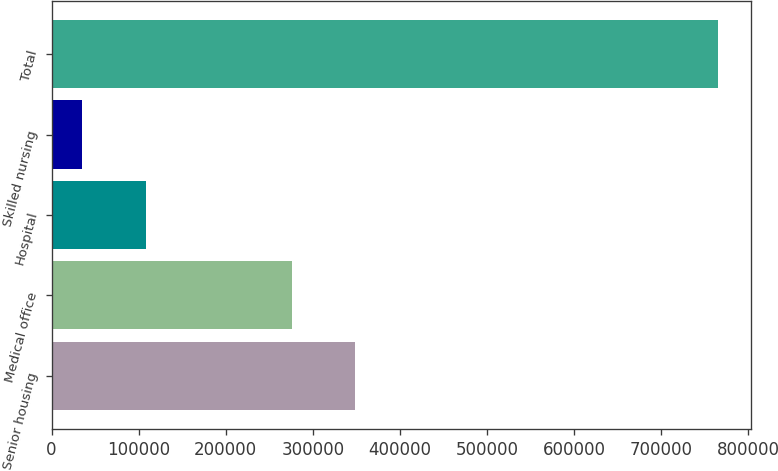Convert chart. <chart><loc_0><loc_0><loc_500><loc_500><bar_chart><fcel>Senior housing<fcel>Medical office<fcel>Hospital<fcel>Skilled nursing<fcel>Total<nl><fcel>348941<fcel>275951<fcel>108162<fcel>35172<fcel>765074<nl></chart> 